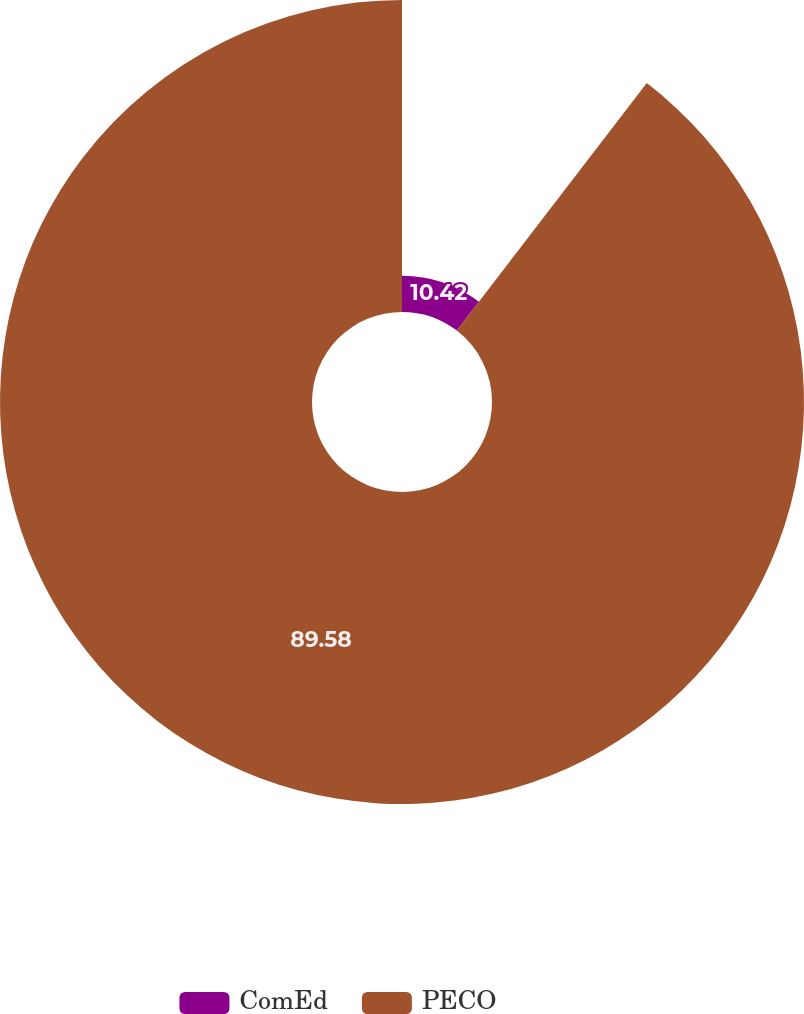Convert chart to OTSL. <chart><loc_0><loc_0><loc_500><loc_500><pie_chart><fcel>ComEd<fcel>PECO<nl><fcel>10.42%<fcel>89.58%<nl></chart> 